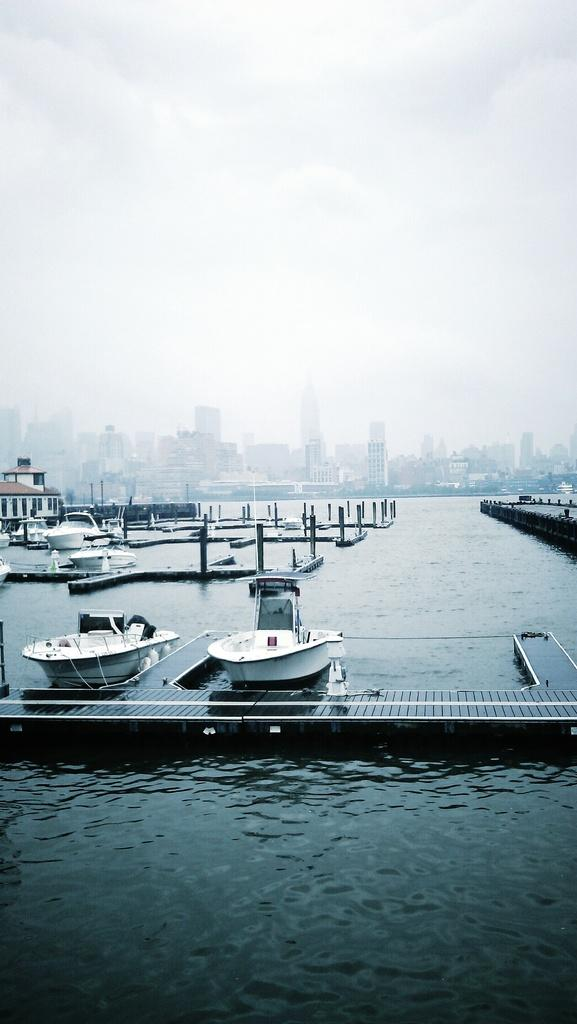What is located in the center of the image in the image? There are boats in the water in the center of the image. What can be seen on the left side of the image? There is a building on the left side of the image. What is visible in the background of the image? There are buildings and the sky visible in the background. What can be observed in the sky? Clouds are present in the sky. What type of rat can be seen operating the apparatus in the image? There is no rat or apparatus present in the image. How does the smash affect the boats in the image? There is no smash present in the image; the boats are stationary in the water. 